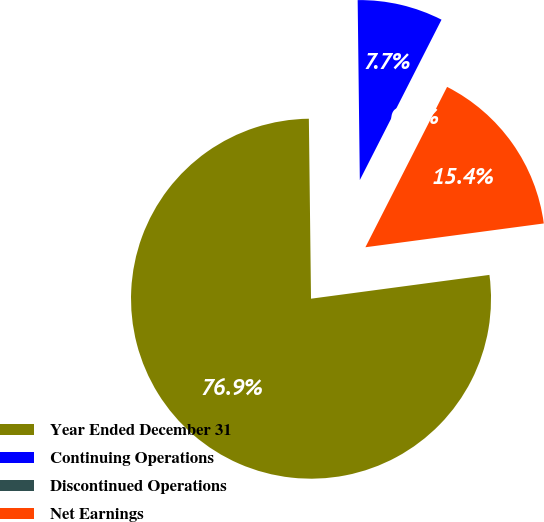Convert chart. <chart><loc_0><loc_0><loc_500><loc_500><pie_chart><fcel>Year Ended December 31<fcel>Continuing Operations<fcel>Discontinued Operations<fcel>Net Earnings<nl><fcel>76.92%<fcel>7.69%<fcel>0.0%<fcel>15.39%<nl></chart> 